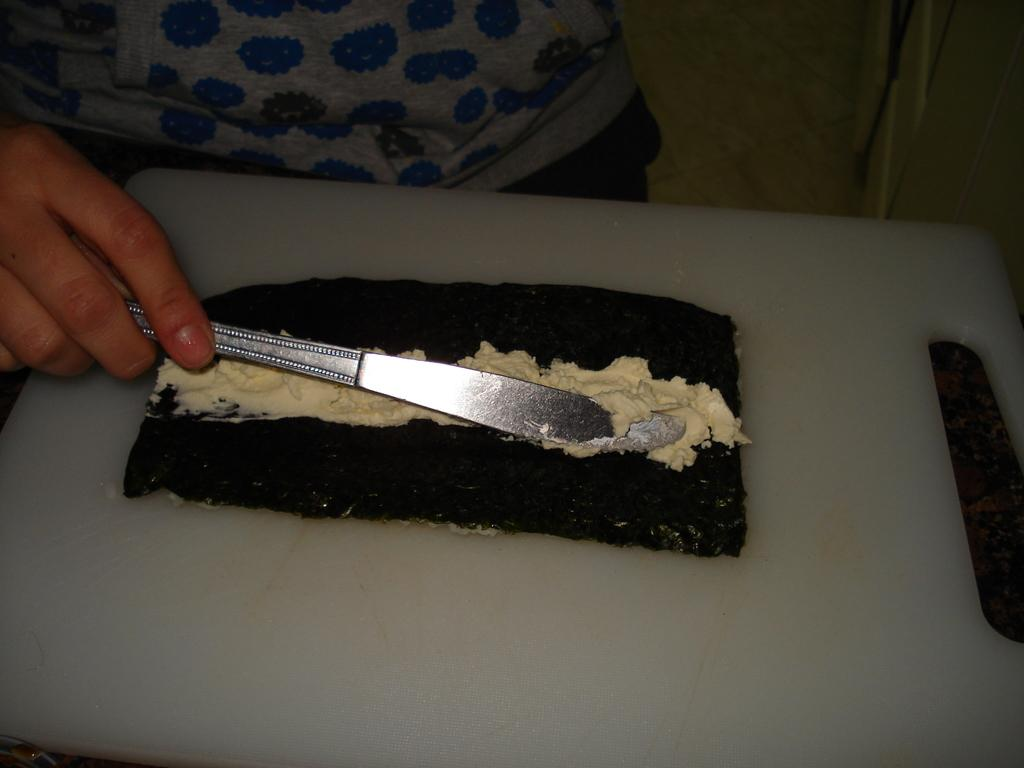What is on the cutting board in the image? There are food items on a cutting board in the image. What is the person in the image doing? There is a hand holding a knife in the image, suggesting that the person is preparing or cutting the food. What other objects can be seen in the image? The provided facts do not specify any other objects, so we cannot answer this question definitively. Where is the playground located in the image? There is no playground present in the image. What type of zephyr can be seen blowing through the kitchen in the image? There is no mention of a zephyr in the image, and zephyrs are not visible in kitchens. 